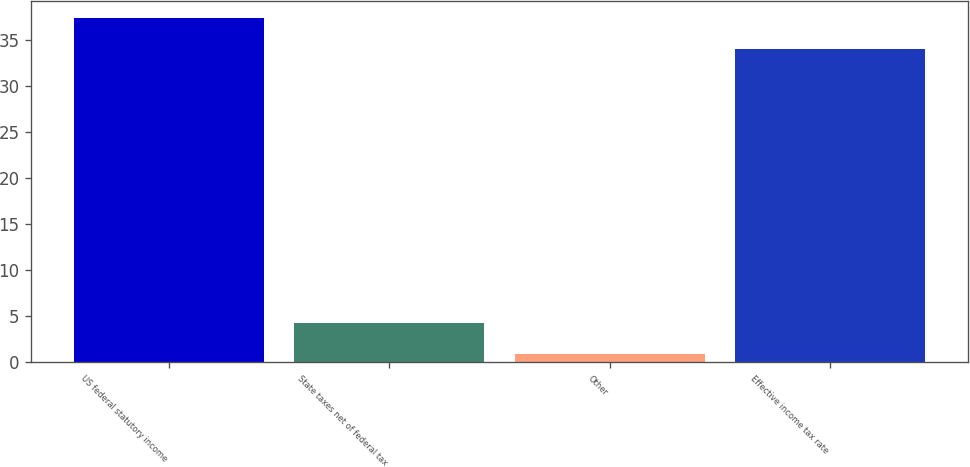<chart> <loc_0><loc_0><loc_500><loc_500><bar_chart><fcel>US federal statutory income<fcel>State taxes net of federal tax<fcel>Other<fcel>Effective income tax rate<nl><fcel>37.41<fcel>4.31<fcel>0.9<fcel>34<nl></chart> 